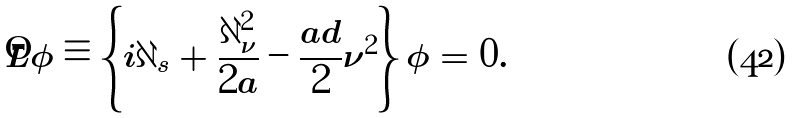Convert formula to latex. <formula><loc_0><loc_0><loc_500><loc_500>\hat { L } \phi \equiv \left \{ i \partial _ { s } + \frac { \partial _ { \nu } ^ { 2 } } { 2 a } - \frac { a d } { 2 } \nu ^ { 2 } \right \} \phi = 0 .</formula> 